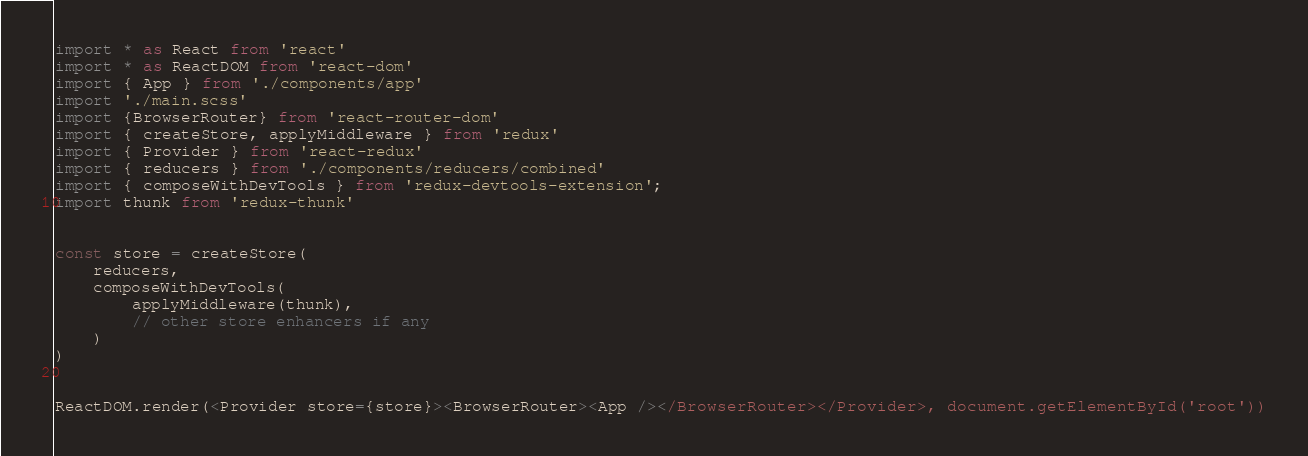Convert code to text. <code><loc_0><loc_0><loc_500><loc_500><_TypeScript_>import * as React from 'react'
import * as ReactDOM from 'react-dom'
import { App } from './components/app'
import './main.scss'
import {BrowserRouter} from 'react-router-dom'
import { createStore, applyMiddleware } from 'redux'
import { Provider } from 'react-redux'
import { reducers } from './components/reducers/combined'
import { composeWithDevTools } from 'redux-devtools-extension';
import thunk from 'redux-thunk'


const store = createStore(
    reducers,
    composeWithDevTools(
        applyMiddleware(thunk),
        // other store enhancers if any
    )
)


ReactDOM.render(<Provider store={store}><BrowserRouter><App /></BrowserRouter></Provider>, document.getElementById('root'))</code> 